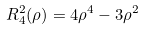Convert formula to latex. <formula><loc_0><loc_0><loc_500><loc_500>R _ { 4 } ^ { 2 } ( \rho ) = 4 \rho ^ { 4 } - 3 \rho ^ { 2 }</formula> 